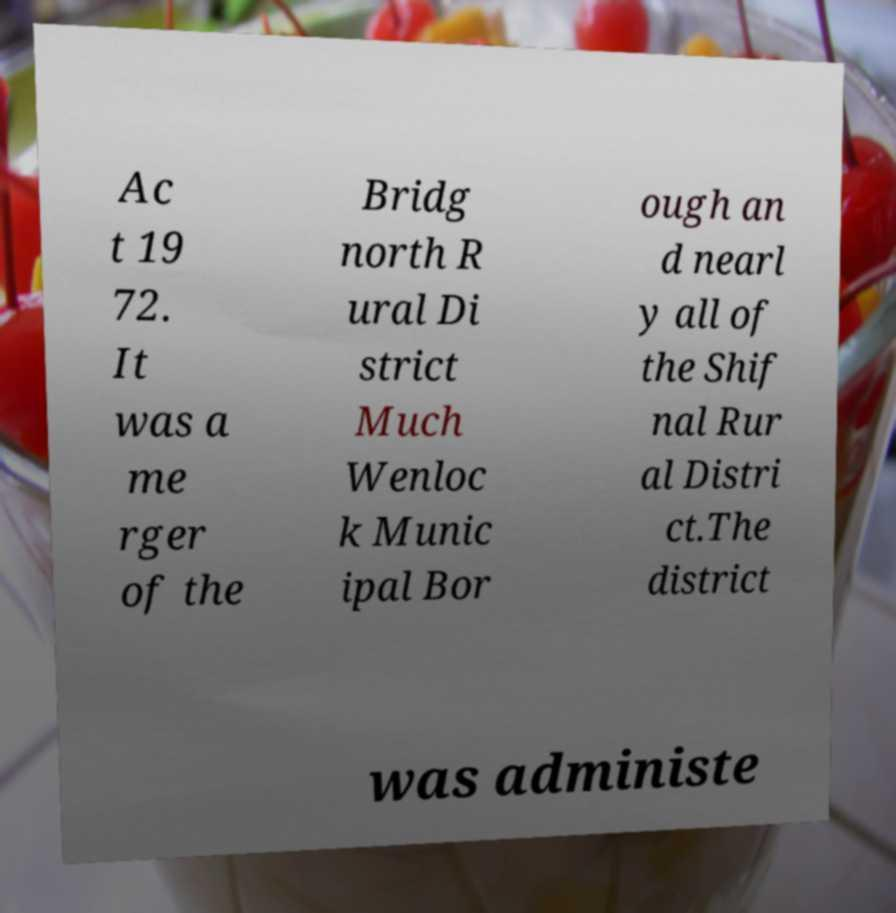Please identify and transcribe the text found in this image. Ac t 19 72. It was a me rger of the Bridg north R ural Di strict Much Wenloc k Munic ipal Bor ough an d nearl y all of the Shif nal Rur al Distri ct.The district was administe 